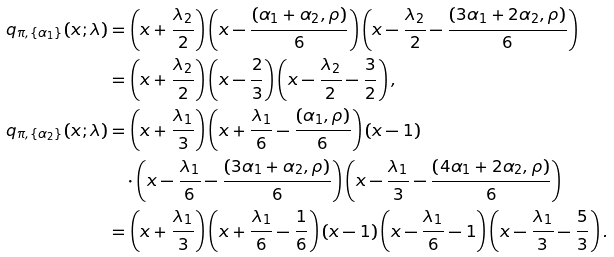<formula> <loc_0><loc_0><loc_500><loc_500>q _ { \pi , \{ \alpha _ { 1 } \} } ( x ; \lambda ) & = \left ( x + \frac { \lambda _ { 2 } } 2 \right ) \left ( x - \frac { ( \alpha _ { 1 } + \alpha _ { 2 } , \rho ) } 6 \right ) \left ( x - \frac { \lambda _ { 2 } } 2 - \frac { ( 3 \alpha _ { 1 } + 2 \alpha _ { 2 } , \rho ) } 6 \right ) \\ & = \left ( x + \frac { \lambda _ { 2 } } 2 \right ) \left ( x - \frac { 2 } { 3 } \right ) \left ( x - \frac { \lambda _ { 2 } } 2 - \frac { 3 } { 2 } \right ) , \\ q _ { \pi , \{ \alpha _ { 2 } \} } ( x ; \lambda ) & = \left ( x + \frac { \lambda _ { 1 } } 3 \right ) \left ( x + \frac { \lambda _ { 1 } } 6 - \frac { ( \alpha _ { 1 } , \rho ) } 6 \right ) \left ( x - 1 \right ) \\ & \quad \cdot \left ( x - \frac { \lambda _ { 1 } } 6 - \frac { ( 3 \alpha _ { 1 } + \alpha _ { 2 } , \rho ) } 6 \right ) \left ( x - \frac { \lambda _ { 1 } } 3 - \frac { ( 4 \alpha _ { 1 } + 2 \alpha _ { 2 } , \rho ) } 6 \right ) \\ & = \left ( x + \frac { \lambda _ { 1 } } 3 \right ) \left ( x + \frac { \lambda _ { 1 } } 6 - \frac { 1 } { 6 } \right ) \left ( x - 1 \right ) \left ( x - \frac { \lambda _ { 1 } } 6 - 1 \right ) \left ( x - \frac { \lambda _ { 1 } } 3 - \frac { 5 } { 3 } \right ) .</formula> 